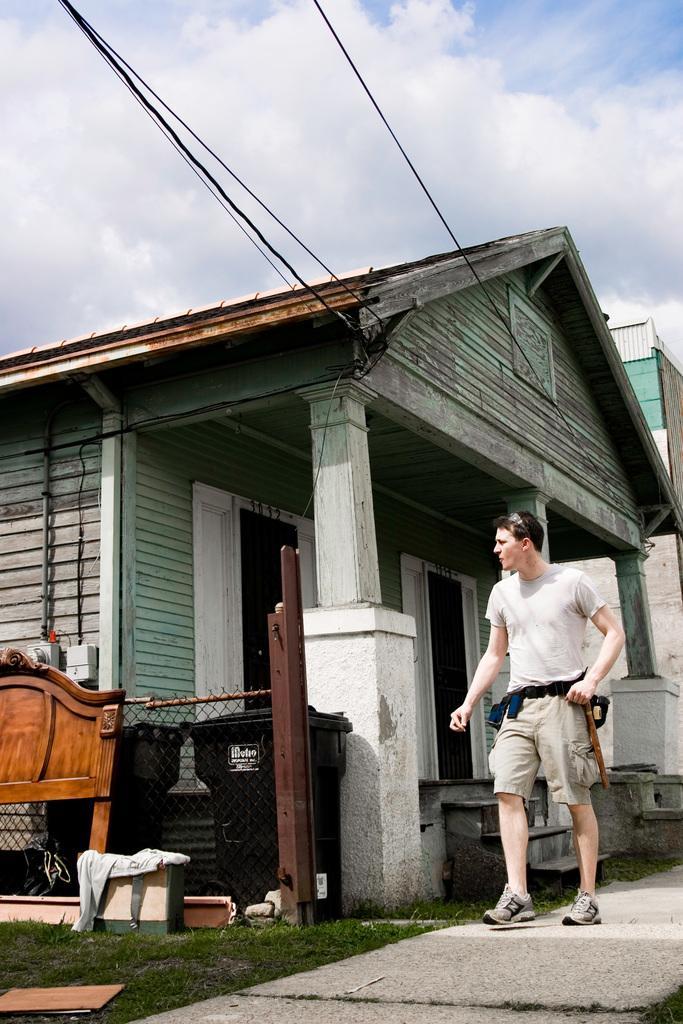Could you give a brief overview of what you see in this image? In this image there is the sky, there are clouds in the sky, there is a building truncated towards the right of the image, there is a house, there is a person walking, there is grass, there are wires truncated, there are doors, there are objects truncated towards the left of the image, there are objects on the grass. 